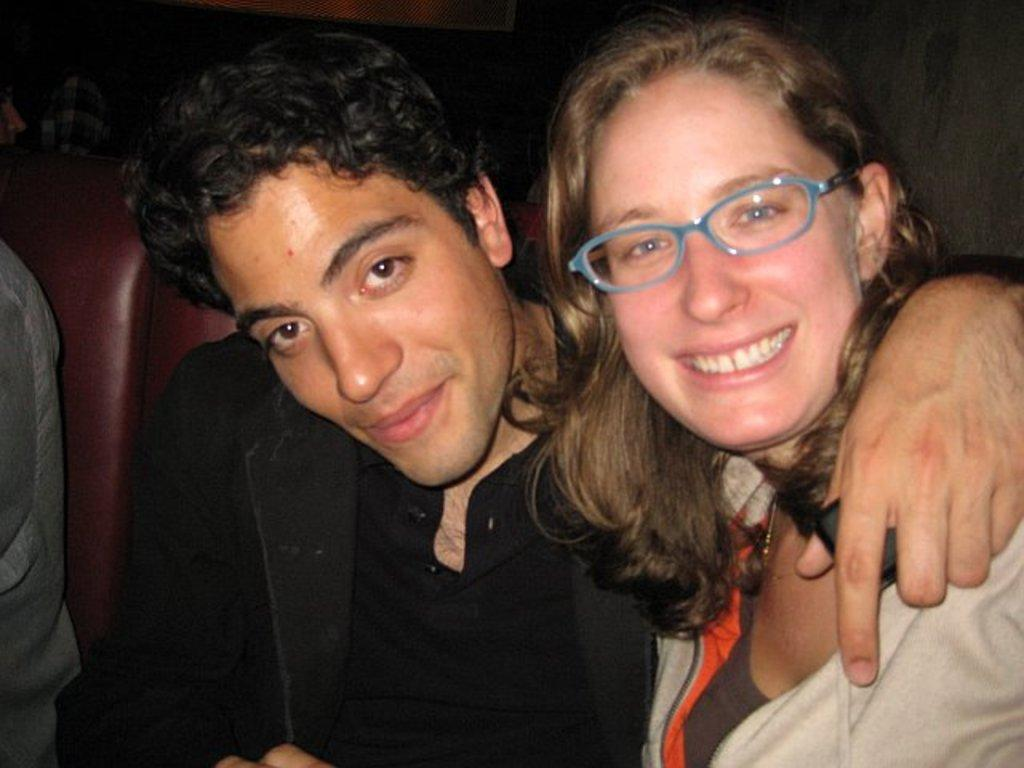How many people are present in the image? There are two persons sitting in the image. What are the persons sitting on? There are chairs in the image. What can be observed about the background of the image? The background of the image is dark. What type of crow is perched on the shoulder of one of the persons in the image? There is no crow present in the image; it only features two persons sitting on chairs with a dark background. 